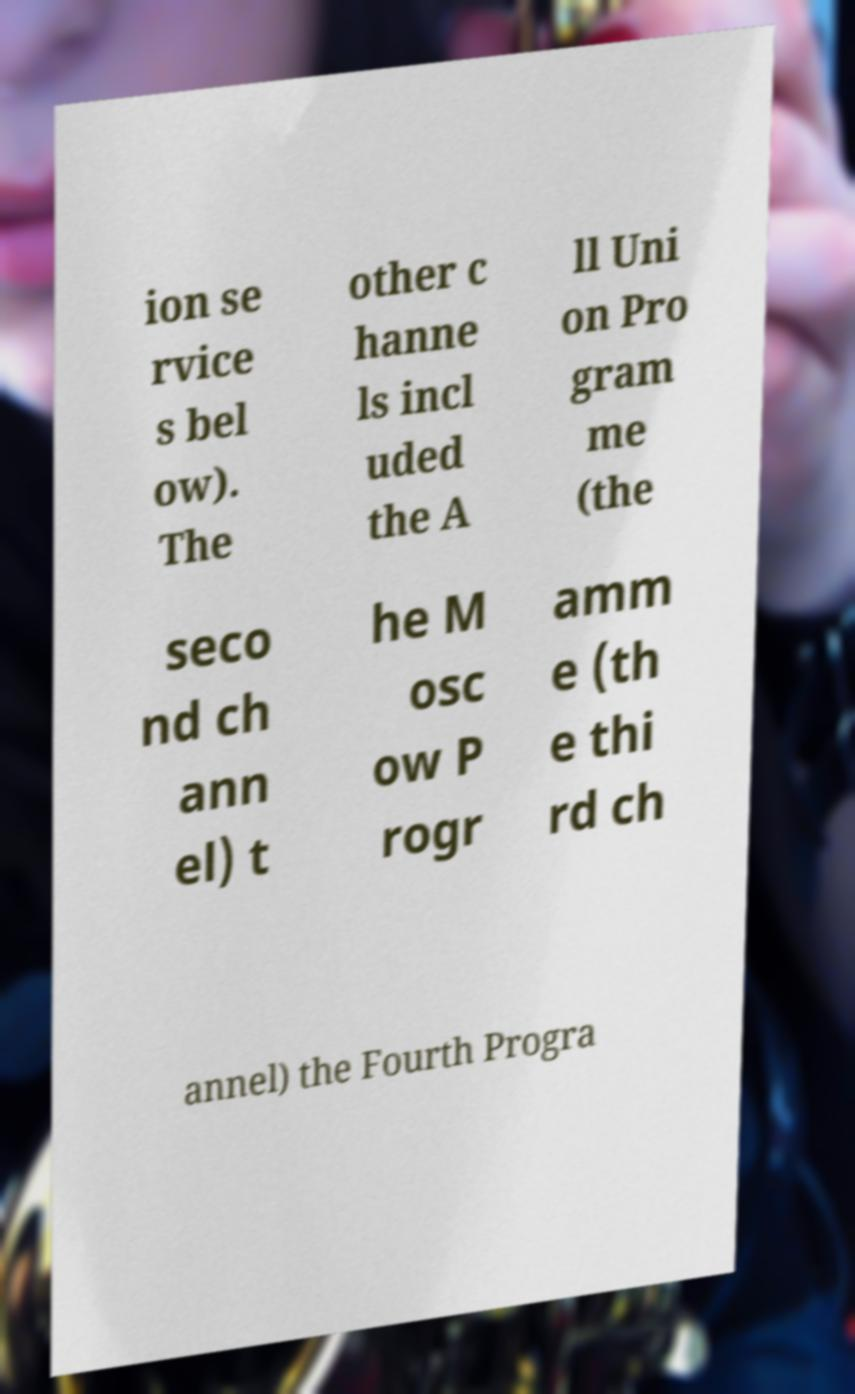Can you accurately transcribe the text from the provided image for me? ion se rvice s bel ow). The other c hanne ls incl uded the A ll Uni on Pro gram me (the seco nd ch ann el) t he M osc ow P rogr amm e (th e thi rd ch annel) the Fourth Progra 